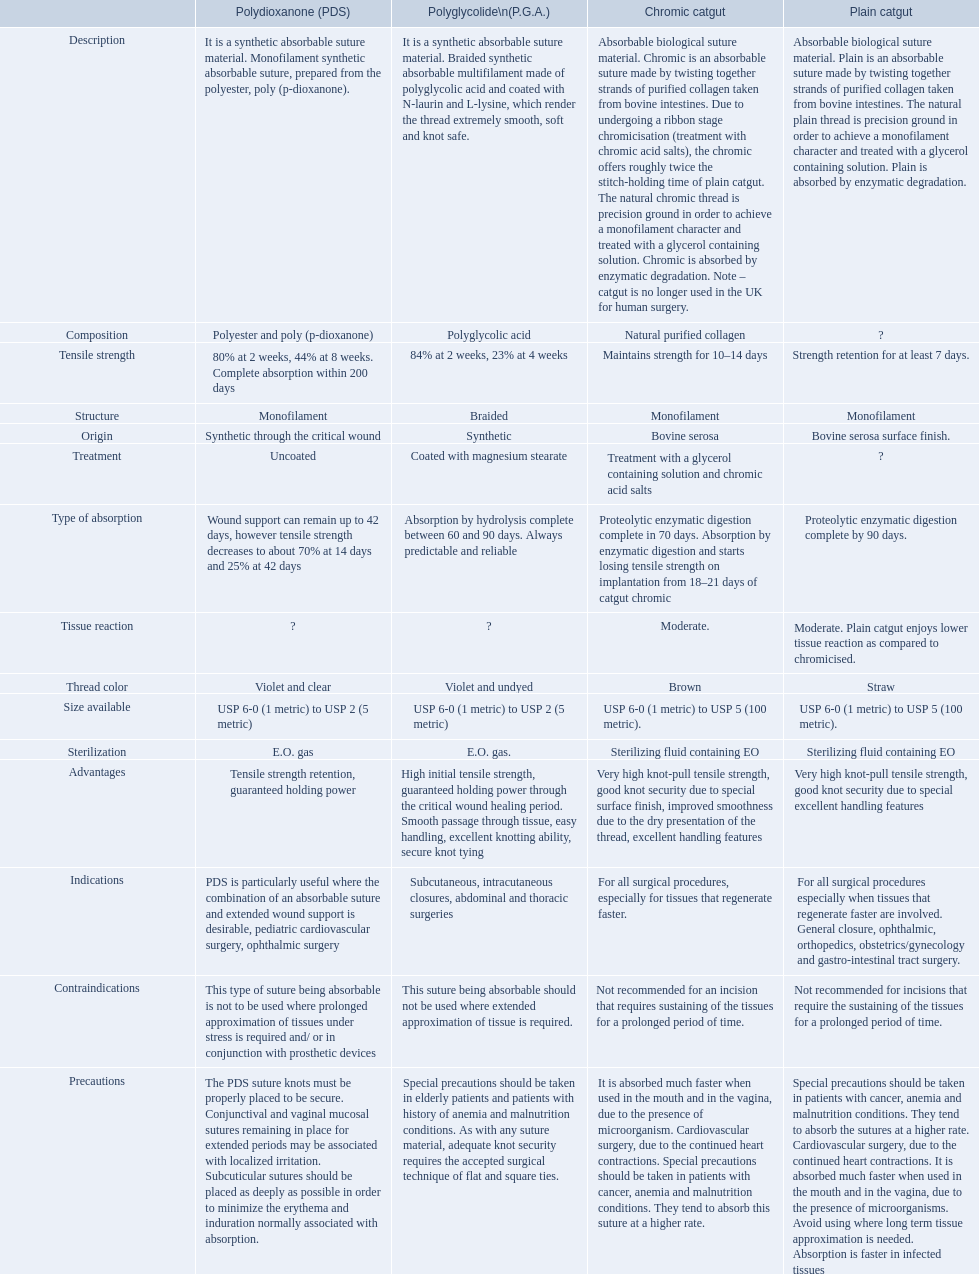Which are the different tensile strengths of the suture materials in the comparison chart? Strength retention for at least 7 days., Maintains strength for 10–14 days, 84% at 2 weeks, 23% at 4 weeks, 80% at 2 weeks, 44% at 8 weeks. Complete absorption within 200 days. Of these, which belongs to plain catgut? Strength retention for at least 7 days. 